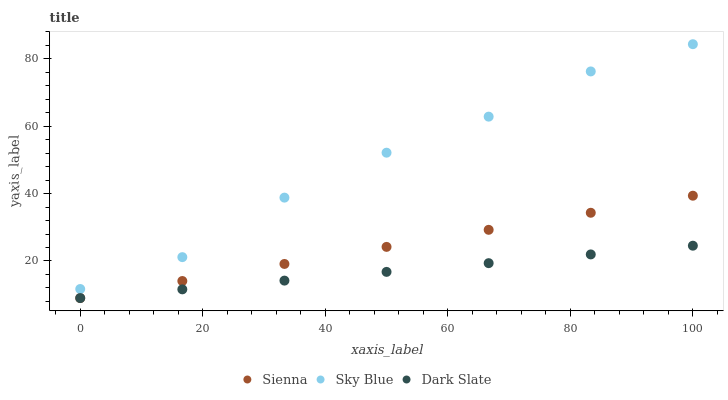Does Dark Slate have the minimum area under the curve?
Answer yes or no. Yes. Does Sky Blue have the maximum area under the curve?
Answer yes or no. Yes. Does Sky Blue have the minimum area under the curve?
Answer yes or no. No. Does Dark Slate have the maximum area under the curve?
Answer yes or no. No. Is Dark Slate the smoothest?
Answer yes or no. Yes. Is Sky Blue the roughest?
Answer yes or no. Yes. Is Sky Blue the smoothest?
Answer yes or no. No. Is Dark Slate the roughest?
Answer yes or no. No. Does Sienna have the lowest value?
Answer yes or no. Yes. Does Sky Blue have the lowest value?
Answer yes or no. No. Does Sky Blue have the highest value?
Answer yes or no. Yes. Does Dark Slate have the highest value?
Answer yes or no. No. Is Sienna less than Sky Blue?
Answer yes or no. Yes. Is Sky Blue greater than Sienna?
Answer yes or no. Yes. Does Dark Slate intersect Sienna?
Answer yes or no. Yes. Is Dark Slate less than Sienna?
Answer yes or no. No. Is Dark Slate greater than Sienna?
Answer yes or no. No. Does Sienna intersect Sky Blue?
Answer yes or no. No. 